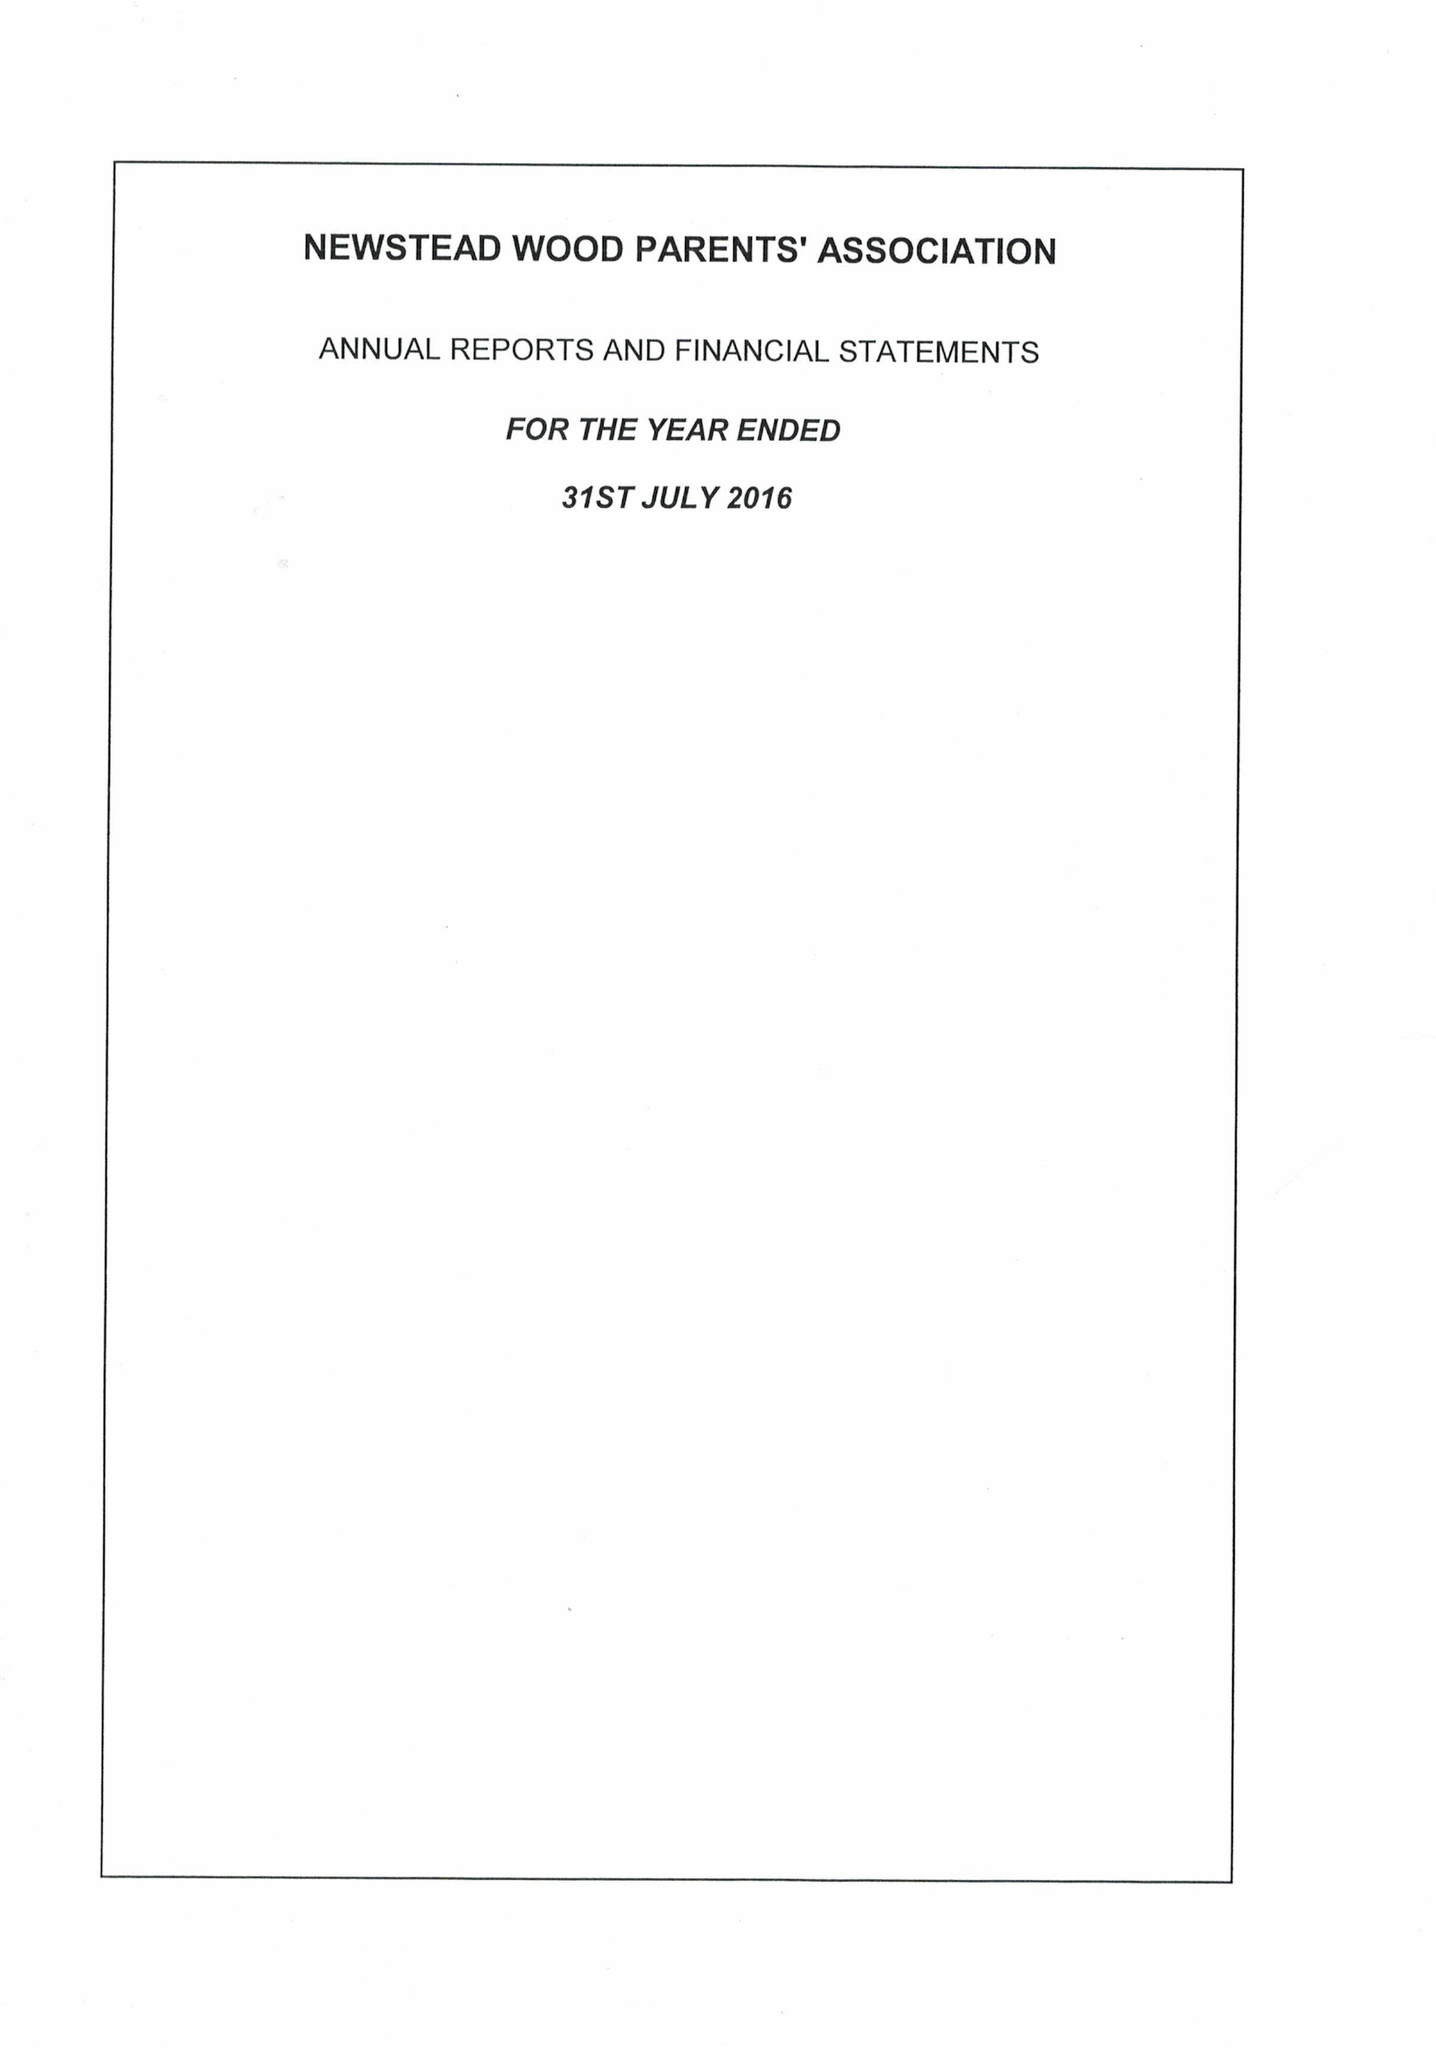What is the value for the charity_number?
Answer the question using a single word or phrase. 272614 